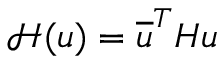<formula> <loc_0><loc_0><loc_500><loc_500>\mathcal { H } ( u ) = \overline { u } ^ { T } H u</formula> 